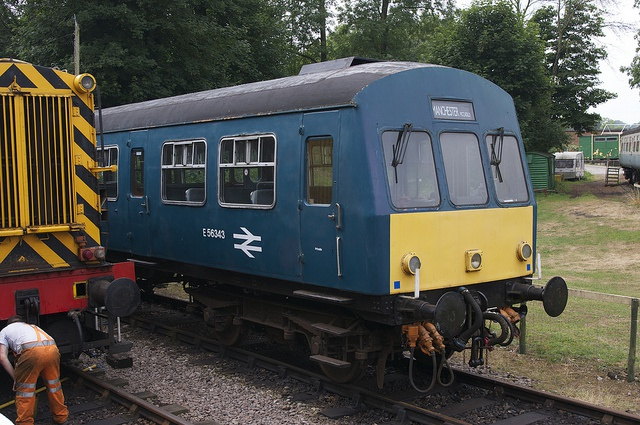Describe the objects in this image and their specific colors. I can see train in darkgreen, black, blue, darkblue, and gray tones, train in darkgreen, black, orange, maroon, and olive tones, people in darkgreen, maroon, black, brown, and lavender tones, and train in darkgreen, darkgray, black, and gray tones in this image. 